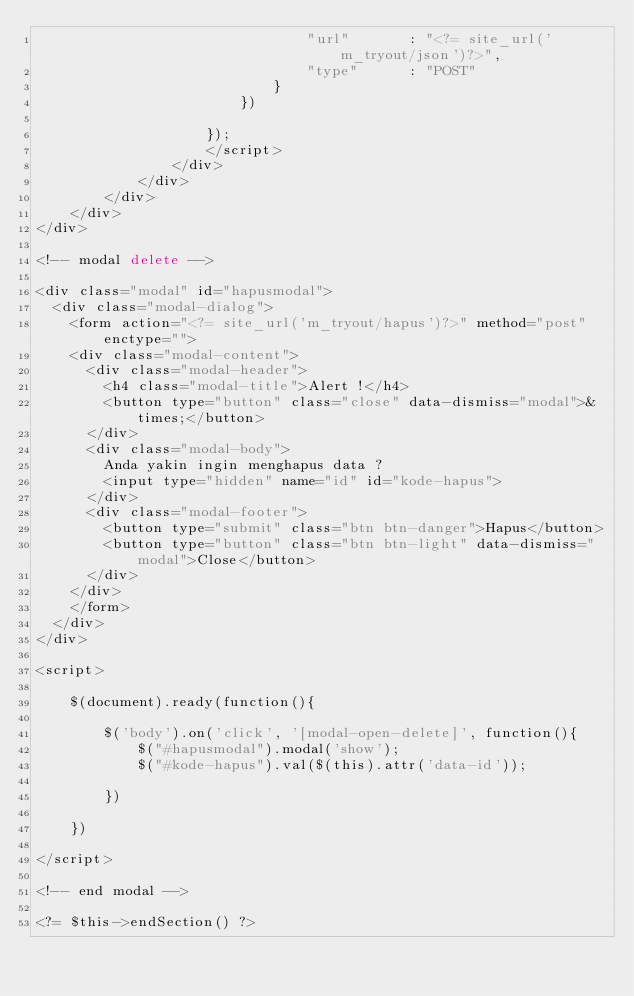<code> <loc_0><loc_0><loc_500><loc_500><_PHP_>                                "url"       : "<?= site_url('m_tryout/json')?>",
                                "type"      : "POST"
                            }
                        })

                    });
                    </script>
                </div>
            </div>
        </div>
    </div>
</div>

<!-- modal delete -->

<div class="modal" id="hapusmodal">
  <div class="modal-dialog">
    <form action="<?= site_url('m_tryout/hapus')?>" method="post" enctype="">
    <div class="modal-content">
      <div class="modal-header">
        <h4 class="modal-title">Alert !</h4>
        <button type="button" class="close" data-dismiss="modal">&times;</button>
      </div>
      <div class="modal-body">
        Anda yakin ingin menghapus data ?
        <input type="hidden" name="id" id="kode-hapus"> 
      </div>
      <div class="modal-footer">
        <button type="submit" class="btn btn-danger">Hapus</button>
        <button type="button" class="btn btn-light" data-dismiss="modal">Close</button>
      </div>
    </div>
    </form>
  </div>
</div>

<script>

    $(document).ready(function(){

        $('body').on('click', '[modal-open-delete]', function(){
            $("#hapusmodal").modal('show');
            $("#kode-hapus").val($(this).attr('data-id'));

        })

    })

</script>

<!-- end modal -->

<?= $this->endSection() ?></code> 